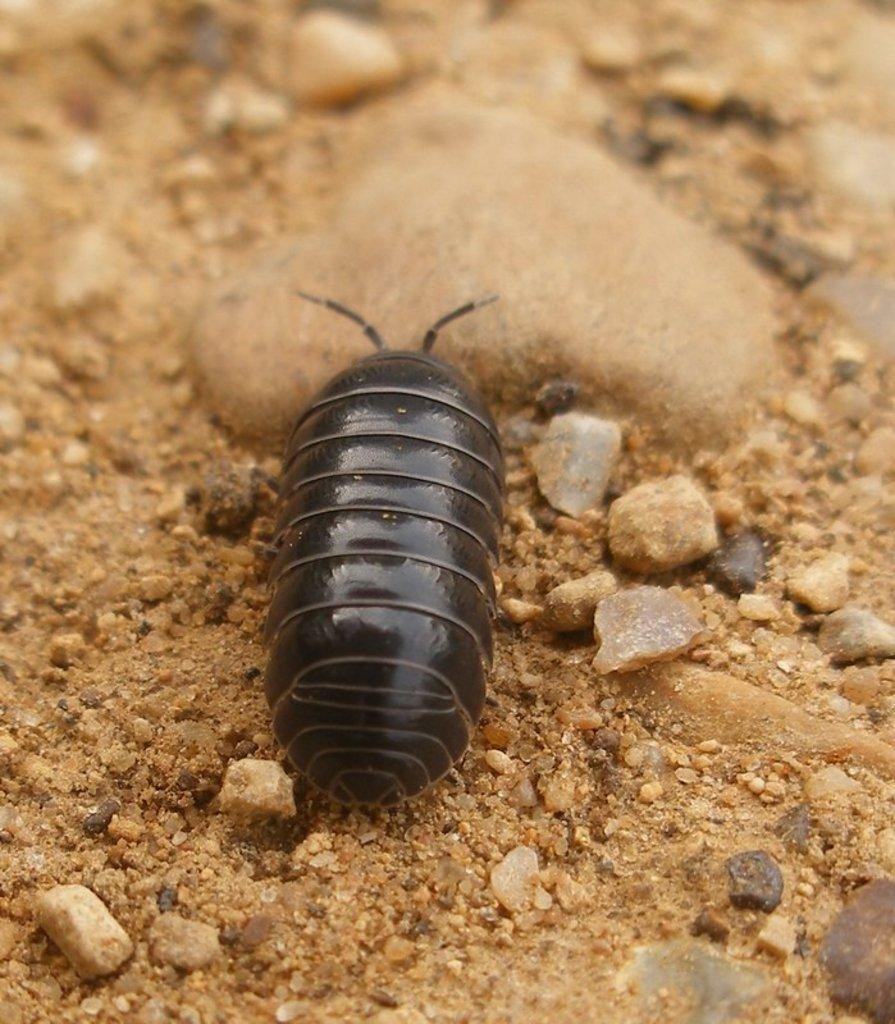What type of insect is in the image? There is a black color insect in the image. Where is the insect located? The insect is on the sand. What else can be seen in the image besides the insect? There are stones visible in the image. What type of hands can be seen holding the knife in the image? There is no knife or hands present in the image; it only features a black color insect on the sand and stones. 